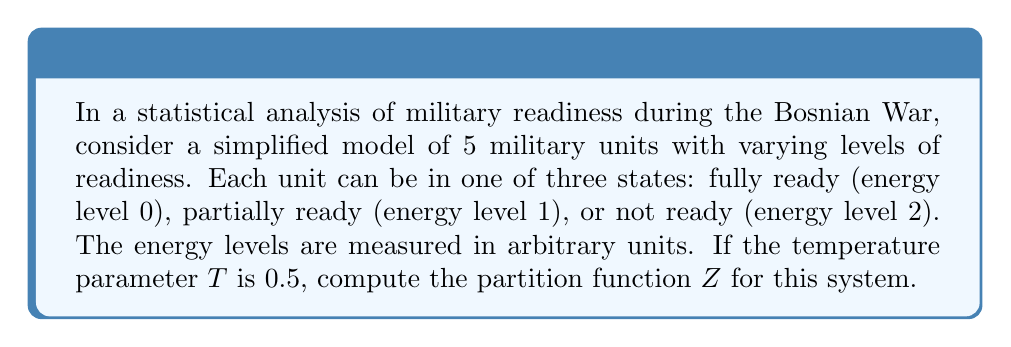Show me your answer to this math problem. To solve this problem, we'll follow these steps:

1) Recall the formula for the partition function:
   $$Z = \sum_{i} g_i e^{-\beta E_i}$$
   where $g_i$ is the degeneracy of state i, $E_i$ is the energy of state i, and $\beta = \frac{1}{k_B T}$.

2) In this case, we have:
   - 3 energy levels: $E_1 = 0$, $E_2 = 1$, $E_3 = 2$
   - Temperature T = 0.5
   - 5 units, each can be in any of the 3 states

3) We need to calculate $\beta$:
   $$\beta = \frac{1}{k_B T} = \frac{1}{0.5} = 2$$
   (assuming $k_B = 1$ for simplicity)

4) Now, let's calculate the Boltzmann factors for each energy level:
   - For $E_1 = 0$: $e^{-\beta E_1} = e^{-2 \cdot 0} = 1$
   - For $E_2 = 1$: $e^{-\beta E_2} = e^{-2 \cdot 1} = e^{-2}$
   - For $E_3 = 2$: $e^{-\beta E_3} = e^{-2 \cdot 2} = e^{-4}$

5) For a single unit, the partition function would be:
   $$Z_1 = 1 + e^{-2} + e^{-4}$$

6) Since we have 5 independent units, and each can be in any state, the total partition function is:
   $$Z = (Z_1)^5 = (1 + e^{-2} + e^{-4})^5$$

7) This can be simplified numerically:
   $$Z \approx (1.1436)^5 \approx 1.9477$$
Answer: $Z \approx 1.9477$ 